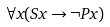Convert formula to latex. <formula><loc_0><loc_0><loc_500><loc_500>\forall x ( S x \rightarrow \neg P x )</formula> 